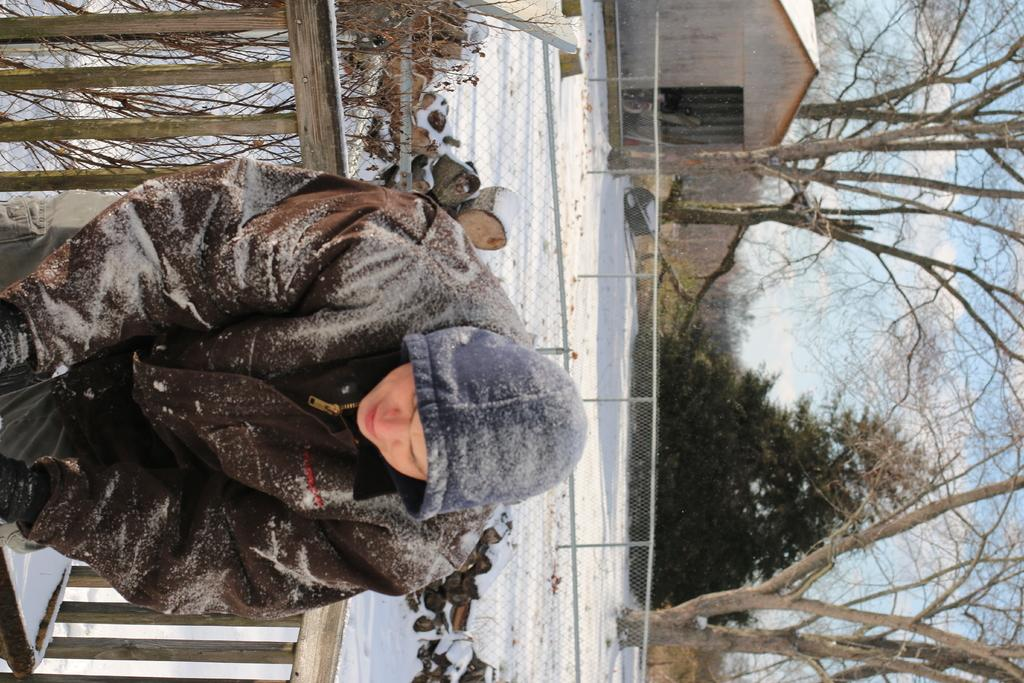What can be seen in the image? There is a person in the image. What is the person wearing? The person is wearing clothes and gloves. What is located behind the person? There is a fence, a wood log, and trees behind the person. How would you describe the sky in the image? The sky is cloudy and pale blue. What type of building is visible in the image? This is a house. How many cows are grazing on the ground in the image? There are no cows present in the image; it features a person, a fence, a wood log, trees, and a house. What is the cause of death for the person in the image? There is no indication of death or any harm to the person in the image. 